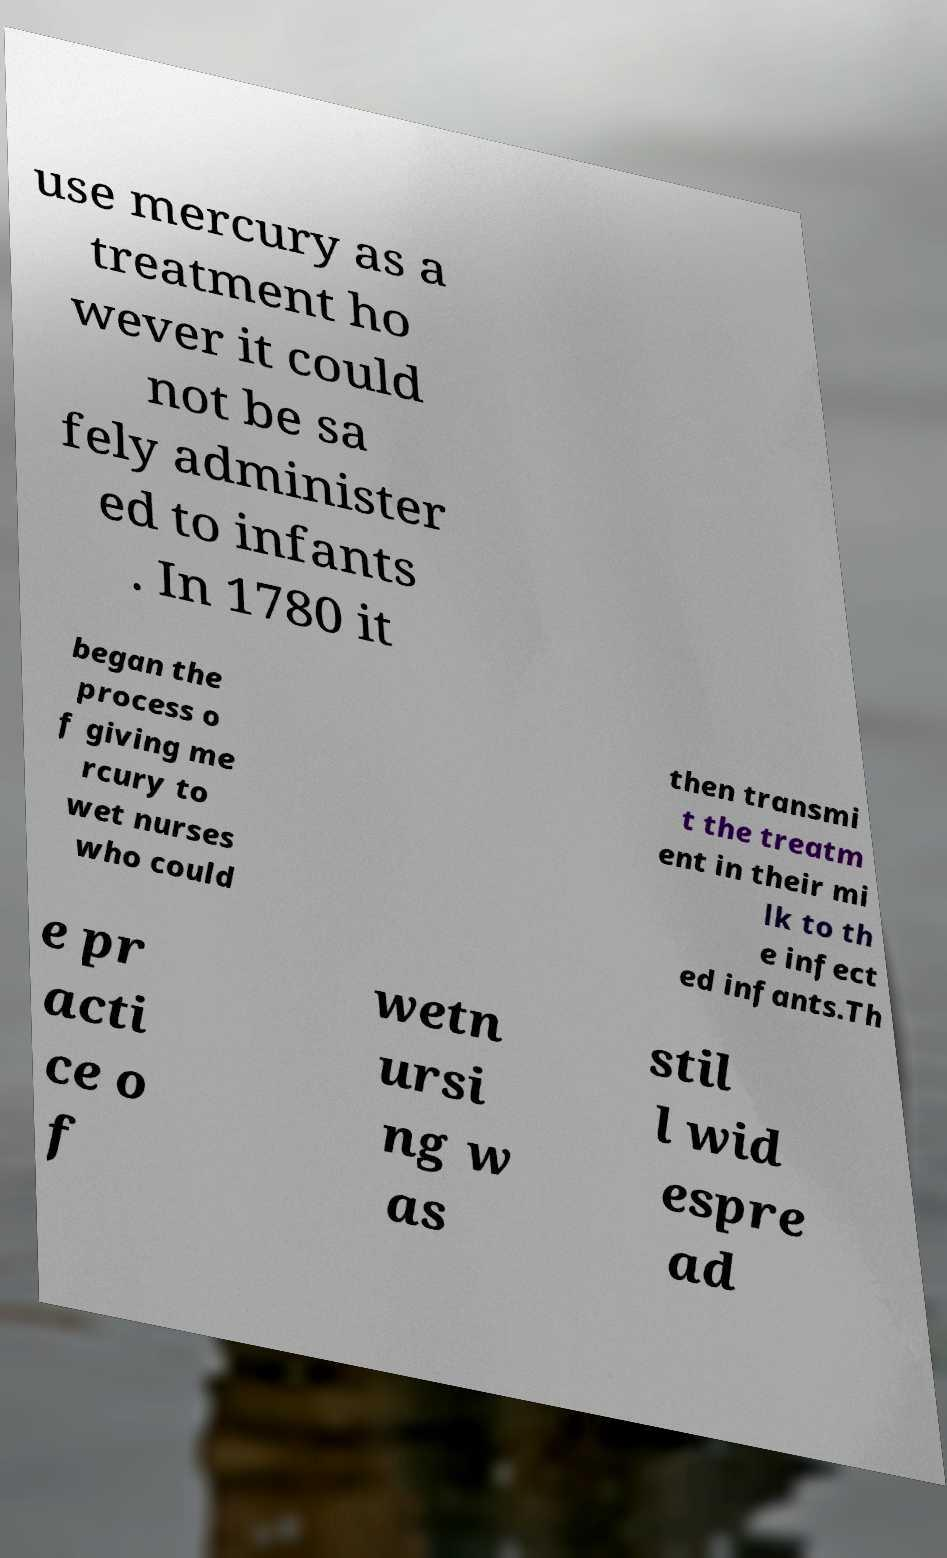Can you read and provide the text displayed in the image?This photo seems to have some interesting text. Can you extract and type it out for me? use mercury as a treatment ho wever it could not be sa fely administer ed to infants . In 1780 it began the process o f giving me rcury to wet nurses who could then transmi t the treatm ent in their mi lk to th e infect ed infants.Th e pr acti ce o f wetn ursi ng w as stil l wid espre ad 